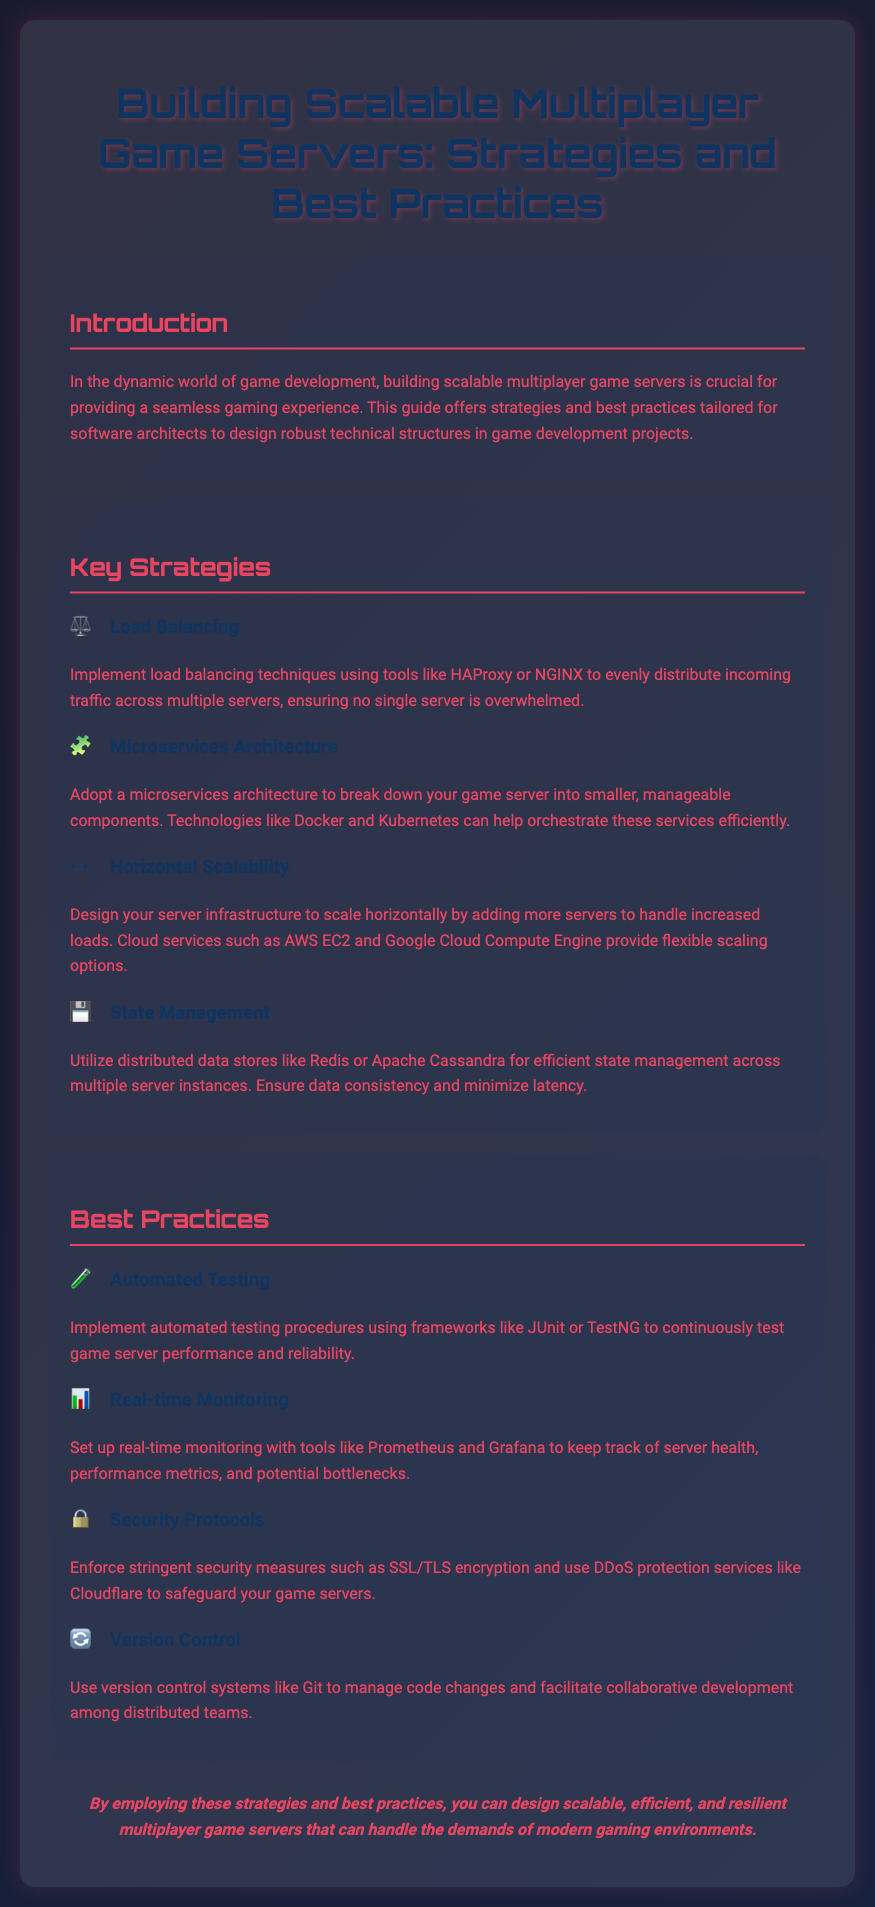What is the primary focus of the flyer? The flyer primarily focuses on building scalable multiplayer game servers and offers strategies and best practices for software architects.
Answer: Building scalable multiplayer game servers What architecture does the flyer recommend adopting? The flyer recommends adopting a microservices architecture to break down game servers into manageable components.
Answer: Microservices architecture Which cloud service is mentioned for horizontal scalability? The flyer mentions AWS EC2 as a cloud service that provides flexible scaling options for horizontal scalability.
Answer: AWS EC2 What tool is suggested for real-time monitoring? The flyer suggests using Prometheus for real-time monitoring of server health and performance metrics.
Answer: Prometheus What is one of the security protocols mentioned? The flyer mentions SSL/TLS encryption as one of the stringent security protocols to enforce.
Answer: SSL/TLS encryption How many key strategies are listed in the flyer? The flyer lists four key strategies for building scalable multiplayer game servers.
Answer: Four Which data store is recommended for state management? The flyer recommends using Redis for efficient state management across multiple server instances.
Answer: Redis What is the concluding statement's focus? The concluding statement focuses on designing scalable, efficient, and resilient multiplayer game servers.
Answer: Scalable, efficient, and resilient multiplayer game servers What practice does the flyer advise to ensure reliability? The flyer advises implementing automated testing procedures to ensure game server performance and reliability.
Answer: Automated testing 